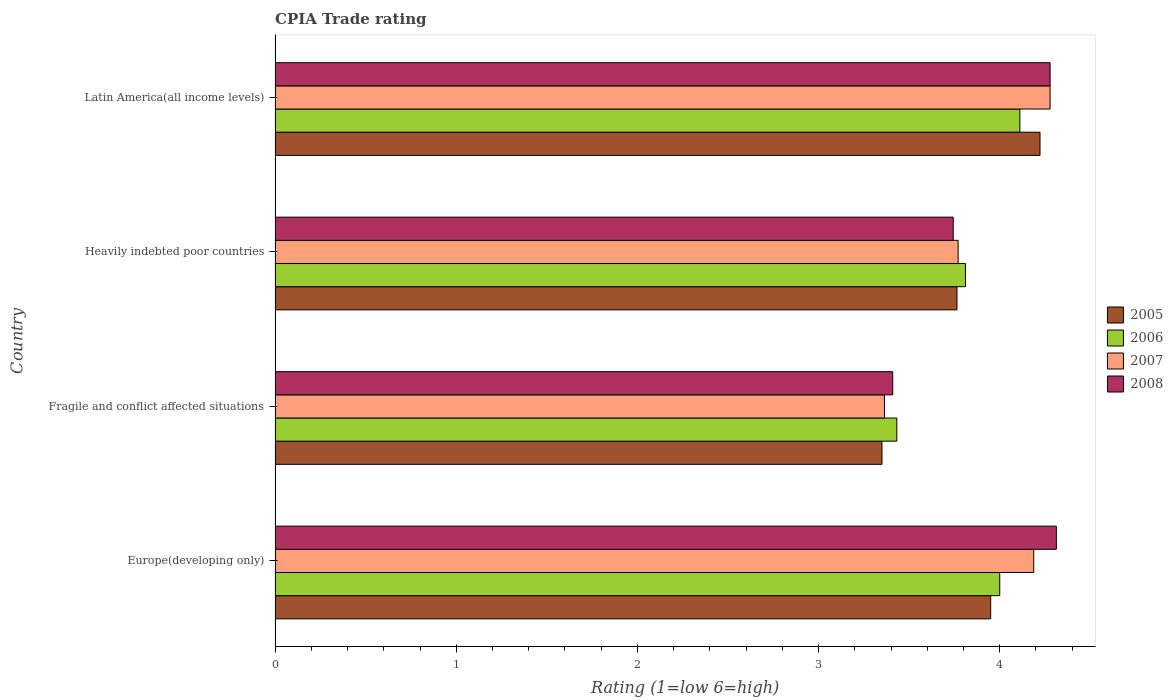Are the number of bars on each tick of the Y-axis equal?
Make the answer very short. Yes. What is the label of the 1st group of bars from the top?
Offer a very short reply. Latin America(all income levels). What is the CPIA rating in 2008 in Heavily indebted poor countries?
Ensure brevity in your answer.  3.74. Across all countries, what is the maximum CPIA rating in 2008?
Give a very brief answer. 4.31. Across all countries, what is the minimum CPIA rating in 2006?
Your answer should be very brief. 3.43. In which country was the CPIA rating in 2008 maximum?
Offer a very short reply. Europe(developing only). In which country was the CPIA rating in 2008 minimum?
Your response must be concise. Fragile and conflict affected situations. What is the total CPIA rating in 2007 in the graph?
Provide a succinct answer. 15.6. What is the difference between the CPIA rating in 2007 in Europe(developing only) and that in Fragile and conflict affected situations?
Your response must be concise. 0.82. What is the difference between the CPIA rating in 2008 in Heavily indebted poor countries and the CPIA rating in 2007 in Fragile and conflict affected situations?
Offer a terse response. 0.38. What is the average CPIA rating in 2007 per country?
Your answer should be very brief. 3.9. What is the difference between the CPIA rating in 2008 and CPIA rating in 2006 in Latin America(all income levels)?
Give a very brief answer. 0.17. In how many countries, is the CPIA rating in 2008 greater than 3.4 ?
Keep it short and to the point. 4. What is the ratio of the CPIA rating in 2005 in Fragile and conflict affected situations to that in Latin America(all income levels)?
Provide a succinct answer. 0.79. Is the difference between the CPIA rating in 2008 in Europe(developing only) and Fragile and conflict affected situations greater than the difference between the CPIA rating in 2006 in Europe(developing only) and Fragile and conflict affected situations?
Make the answer very short. Yes. What is the difference between the highest and the second highest CPIA rating in 2006?
Ensure brevity in your answer.  0.11. What is the difference between the highest and the lowest CPIA rating in 2008?
Offer a terse response. 0.9. Is the sum of the CPIA rating in 2008 in Heavily indebted poor countries and Latin America(all income levels) greater than the maximum CPIA rating in 2007 across all countries?
Provide a succinct answer. Yes. What does the 2nd bar from the top in Heavily indebted poor countries represents?
Offer a terse response. 2007. What does the 1st bar from the bottom in Heavily indebted poor countries represents?
Your answer should be very brief. 2005. Are all the bars in the graph horizontal?
Ensure brevity in your answer.  Yes. How many countries are there in the graph?
Provide a succinct answer. 4. What is the difference between two consecutive major ticks on the X-axis?
Your answer should be very brief. 1. Are the values on the major ticks of X-axis written in scientific E-notation?
Your response must be concise. No. Does the graph contain grids?
Offer a terse response. No. How many legend labels are there?
Offer a terse response. 4. How are the legend labels stacked?
Ensure brevity in your answer.  Vertical. What is the title of the graph?
Make the answer very short. CPIA Trade rating. Does "1967" appear as one of the legend labels in the graph?
Keep it short and to the point. No. What is the Rating (1=low 6=high) in 2005 in Europe(developing only)?
Offer a very short reply. 3.95. What is the Rating (1=low 6=high) of 2006 in Europe(developing only)?
Provide a succinct answer. 4. What is the Rating (1=low 6=high) in 2007 in Europe(developing only)?
Your answer should be compact. 4.19. What is the Rating (1=low 6=high) in 2008 in Europe(developing only)?
Keep it short and to the point. 4.31. What is the Rating (1=low 6=high) in 2005 in Fragile and conflict affected situations?
Offer a very short reply. 3.35. What is the Rating (1=low 6=high) of 2006 in Fragile and conflict affected situations?
Provide a succinct answer. 3.43. What is the Rating (1=low 6=high) in 2007 in Fragile and conflict affected situations?
Provide a short and direct response. 3.36. What is the Rating (1=low 6=high) of 2008 in Fragile and conflict affected situations?
Offer a terse response. 3.41. What is the Rating (1=low 6=high) of 2005 in Heavily indebted poor countries?
Your answer should be compact. 3.76. What is the Rating (1=low 6=high) in 2006 in Heavily indebted poor countries?
Give a very brief answer. 3.81. What is the Rating (1=low 6=high) in 2007 in Heavily indebted poor countries?
Keep it short and to the point. 3.77. What is the Rating (1=low 6=high) of 2008 in Heavily indebted poor countries?
Offer a very short reply. 3.74. What is the Rating (1=low 6=high) in 2005 in Latin America(all income levels)?
Ensure brevity in your answer.  4.22. What is the Rating (1=low 6=high) in 2006 in Latin America(all income levels)?
Your answer should be very brief. 4.11. What is the Rating (1=low 6=high) in 2007 in Latin America(all income levels)?
Your answer should be very brief. 4.28. What is the Rating (1=low 6=high) of 2008 in Latin America(all income levels)?
Make the answer very short. 4.28. Across all countries, what is the maximum Rating (1=low 6=high) in 2005?
Give a very brief answer. 4.22. Across all countries, what is the maximum Rating (1=low 6=high) in 2006?
Provide a short and direct response. 4.11. Across all countries, what is the maximum Rating (1=low 6=high) of 2007?
Offer a very short reply. 4.28. Across all countries, what is the maximum Rating (1=low 6=high) in 2008?
Provide a succinct answer. 4.31. Across all countries, what is the minimum Rating (1=low 6=high) in 2005?
Offer a terse response. 3.35. Across all countries, what is the minimum Rating (1=low 6=high) of 2006?
Offer a very short reply. 3.43. Across all countries, what is the minimum Rating (1=low 6=high) of 2007?
Make the answer very short. 3.36. Across all countries, what is the minimum Rating (1=low 6=high) of 2008?
Your answer should be very brief. 3.41. What is the total Rating (1=low 6=high) in 2005 in the graph?
Make the answer very short. 15.29. What is the total Rating (1=low 6=high) of 2006 in the graph?
Your answer should be very brief. 15.35. What is the total Rating (1=low 6=high) of 2007 in the graph?
Keep it short and to the point. 15.6. What is the total Rating (1=low 6=high) in 2008 in the graph?
Keep it short and to the point. 15.74. What is the difference between the Rating (1=low 6=high) of 2005 in Europe(developing only) and that in Fragile and conflict affected situations?
Give a very brief answer. 0.6. What is the difference between the Rating (1=low 6=high) of 2006 in Europe(developing only) and that in Fragile and conflict affected situations?
Your answer should be compact. 0.57. What is the difference between the Rating (1=low 6=high) of 2007 in Europe(developing only) and that in Fragile and conflict affected situations?
Your answer should be compact. 0.82. What is the difference between the Rating (1=low 6=high) of 2008 in Europe(developing only) and that in Fragile and conflict affected situations?
Your answer should be compact. 0.9. What is the difference between the Rating (1=low 6=high) of 2005 in Europe(developing only) and that in Heavily indebted poor countries?
Offer a very short reply. 0.19. What is the difference between the Rating (1=low 6=high) in 2006 in Europe(developing only) and that in Heavily indebted poor countries?
Give a very brief answer. 0.19. What is the difference between the Rating (1=low 6=high) of 2007 in Europe(developing only) and that in Heavily indebted poor countries?
Give a very brief answer. 0.42. What is the difference between the Rating (1=low 6=high) of 2008 in Europe(developing only) and that in Heavily indebted poor countries?
Provide a succinct answer. 0.57. What is the difference between the Rating (1=low 6=high) of 2005 in Europe(developing only) and that in Latin America(all income levels)?
Offer a very short reply. -0.27. What is the difference between the Rating (1=low 6=high) of 2006 in Europe(developing only) and that in Latin America(all income levels)?
Give a very brief answer. -0.11. What is the difference between the Rating (1=low 6=high) of 2007 in Europe(developing only) and that in Latin America(all income levels)?
Offer a terse response. -0.09. What is the difference between the Rating (1=low 6=high) of 2008 in Europe(developing only) and that in Latin America(all income levels)?
Your response must be concise. 0.03. What is the difference between the Rating (1=low 6=high) in 2005 in Fragile and conflict affected situations and that in Heavily indebted poor countries?
Offer a very short reply. -0.41. What is the difference between the Rating (1=low 6=high) of 2006 in Fragile and conflict affected situations and that in Heavily indebted poor countries?
Offer a very short reply. -0.38. What is the difference between the Rating (1=low 6=high) in 2007 in Fragile and conflict affected situations and that in Heavily indebted poor countries?
Your answer should be compact. -0.41. What is the difference between the Rating (1=low 6=high) in 2008 in Fragile and conflict affected situations and that in Heavily indebted poor countries?
Your answer should be compact. -0.33. What is the difference between the Rating (1=low 6=high) of 2005 in Fragile and conflict affected situations and that in Latin America(all income levels)?
Your answer should be compact. -0.87. What is the difference between the Rating (1=low 6=high) of 2006 in Fragile and conflict affected situations and that in Latin America(all income levels)?
Provide a short and direct response. -0.68. What is the difference between the Rating (1=low 6=high) of 2007 in Fragile and conflict affected situations and that in Latin America(all income levels)?
Your answer should be very brief. -0.91. What is the difference between the Rating (1=low 6=high) in 2008 in Fragile and conflict affected situations and that in Latin America(all income levels)?
Keep it short and to the point. -0.87. What is the difference between the Rating (1=low 6=high) of 2005 in Heavily indebted poor countries and that in Latin America(all income levels)?
Keep it short and to the point. -0.46. What is the difference between the Rating (1=low 6=high) of 2006 in Heavily indebted poor countries and that in Latin America(all income levels)?
Make the answer very short. -0.3. What is the difference between the Rating (1=low 6=high) of 2007 in Heavily indebted poor countries and that in Latin America(all income levels)?
Give a very brief answer. -0.51. What is the difference between the Rating (1=low 6=high) in 2008 in Heavily indebted poor countries and that in Latin America(all income levels)?
Give a very brief answer. -0.53. What is the difference between the Rating (1=low 6=high) in 2005 in Europe(developing only) and the Rating (1=low 6=high) in 2006 in Fragile and conflict affected situations?
Your answer should be very brief. 0.52. What is the difference between the Rating (1=low 6=high) in 2005 in Europe(developing only) and the Rating (1=low 6=high) in 2007 in Fragile and conflict affected situations?
Keep it short and to the point. 0.59. What is the difference between the Rating (1=low 6=high) in 2005 in Europe(developing only) and the Rating (1=low 6=high) in 2008 in Fragile and conflict affected situations?
Your answer should be compact. 0.54. What is the difference between the Rating (1=low 6=high) of 2006 in Europe(developing only) and the Rating (1=low 6=high) of 2007 in Fragile and conflict affected situations?
Offer a terse response. 0.64. What is the difference between the Rating (1=low 6=high) of 2006 in Europe(developing only) and the Rating (1=low 6=high) of 2008 in Fragile and conflict affected situations?
Provide a succinct answer. 0.59. What is the difference between the Rating (1=low 6=high) of 2007 in Europe(developing only) and the Rating (1=low 6=high) of 2008 in Fragile and conflict affected situations?
Give a very brief answer. 0.78. What is the difference between the Rating (1=low 6=high) in 2005 in Europe(developing only) and the Rating (1=low 6=high) in 2006 in Heavily indebted poor countries?
Keep it short and to the point. 0.14. What is the difference between the Rating (1=low 6=high) of 2005 in Europe(developing only) and the Rating (1=low 6=high) of 2007 in Heavily indebted poor countries?
Provide a succinct answer. 0.18. What is the difference between the Rating (1=low 6=high) of 2005 in Europe(developing only) and the Rating (1=low 6=high) of 2008 in Heavily indebted poor countries?
Make the answer very short. 0.21. What is the difference between the Rating (1=low 6=high) in 2006 in Europe(developing only) and the Rating (1=low 6=high) in 2007 in Heavily indebted poor countries?
Your answer should be compact. 0.23. What is the difference between the Rating (1=low 6=high) of 2006 in Europe(developing only) and the Rating (1=low 6=high) of 2008 in Heavily indebted poor countries?
Ensure brevity in your answer.  0.26. What is the difference between the Rating (1=low 6=high) in 2007 in Europe(developing only) and the Rating (1=low 6=high) in 2008 in Heavily indebted poor countries?
Give a very brief answer. 0.44. What is the difference between the Rating (1=low 6=high) of 2005 in Europe(developing only) and the Rating (1=low 6=high) of 2006 in Latin America(all income levels)?
Keep it short and to the point. -0.16. What is the difference between the Rating (1=low 6=high) of 2005 in Europe(developing only) and the Rating (1=low 6=high) of 2007 in Latin America(all income levels)?
Keep it short and to the point. -0.33. What is the difference between the Rating (1=low 6=high) in 2005 in Europe(developing only) and the Rating (1=low 6=high) in 2008 in Latin America(all income levels)?
Keep it short and to the point. -0.33. What is the difference between the Rating (1=low 6=high) in 2006 in Europe(developing only) and the Rating (1=low 6=high) in 2007 in Latin America(all income levels)?
Offer a very short reply. -0.28. What is the difference between the Rating (1=low 6=high) in 2006 in Europe(developing only) and the Rating (1=low 6=high) in 2008 in Latin America(all income levels)?
Make the answer very short. -0.28. What is the difference between the Rating (1=low 6=high) in 2007 in Europe(developing only) and the Rating (1=low 6=high) in 2008 in Latin America(all income levels)?
Provide a succinct answer. -0.09. What is the difference between the Rating (1=low 6=high) of 2005 in Fragile and conflict affected situations and the Rating (1=low 6=high) of 2006 in Heavily indebted poor countries?
Offer a very short reply. -0.46. What is the difference between the Rating (1=low 6=high) of 2005 in Fragile and conflict affected situations and the Rating (1=low 6=high) of 2007 in Heavily indebted poor countries?
Make the answer very short. -0.42. What is the difference between the Rating (1=low 6=high) in 2005 in Fragile and conflict affected situations and the Rating (1=low 6=high) in 2008 in Heavily indebted poor countries?
Keep it short and to the point. -0.39. What is the difference between the Rating (1=low 6=high) in 2006 in Fragile and conflict affected situations and the Rating (1=low 6=high) in 2007 in Heavily indebted poor countries?
Keep it short and to the point. -0.34. What is the difference between the Rating (1=low 6=high) of 2006 in Fragile and conflict affected situations and the Rating (1=low 6=high) of 2008 in Heavily indebted poor countries?
Provide a succinct answer. -0.31. What is the difference between the Rating (1=low 6=high) in 2007 in Fragile and conflict affected situations and the Rating (1=low 6=high) in 2008 in Heavily indebted poor countries?
Ensure brevity in your answer.  -0.38. What is the difference between the Rating (1=low 6=high) in 2005 in Fragile and conflict affected situations and the Rating (1=low 6=high) in 2006 in Latin America(all income levels)?
Provide a short and direct response. -0.76. What is the difference between the Rating (1=low 6=high) of 2005 in Fragile and conflict affected situations and the Rating (1=low 6=high) of 2007 in Latin America(all income levels)?
Offer a terse response. -0.93. What is the difference between the Rating (1=low 6=high) of 2005 in Fragile and conflict affected situations and the Rating (1=low 6=high) of 2008 in Latin America(all income levels)?
Offer a very short reply. -0.93. What is the difference between the Rating (1=low 6=high) of 2006 in Fragile and conflict affected situations and the Rating (1=low 6=high) of 2007 in Latin America(all income levels)?
Provide a succinct answer. -0.85. What is the difference between the Rating (1=low 6=high) in 2006 in Fragile and conflict affected situations and the Rating (1=low 6=high) in 2008 in Latin America(all income levels)?
Provide a short and direct response. -0.85. What is the difference between the Rating (1=low 6=high) of 2007 in Fragile and conflict affected situations and the Rating (1=low 6=high) of 2008 in Latin America(all income levels)?
Your answer should be compact. -0.91. What is the difference between the Rating (1=low 6=high) in 2005 in Heavily indebted poor countries and the Rating (1=low 6=high) in 2006 in Latin America(all income levels)?
Provide a short and direct response. -0.35. What is the difference between the Rating (1=low 6=high) in 2005 in Heavily indebted poor countries and the Rating (1=low 6=high) in 2007 in Latin America(all income levels)?
Offer a terse response. -0.51. What is the difference between the Rating (1=low 6=high) in 2005 in Heavily indebted poor countries and the Rating (1=low 6=high) in 2008 in Latin America(all income levels)?
Give a very brief answer. -0.51. What is the difference between the Rating (1=low 6=high) in 2006 in Heavily indebted poor countries and the Rating (1=low 6=high) in 2007 in Latin America(all income levels)?
Keep it short and to the point. -0.47. What is the difference between the Rating (1=low 6=high) of 2006 in Heavily indebted poor countries and the Rating (1=low 6=high) of 2008 in Latin America(all income levels)?
Provide a succinct answer. -0.47. What is the difference between the Rating (1=low 6=high) of 2007 in Heavily indebted poor countries and the Rating (1=low 6=high) of 2008 in Latin America(all income levels)?
Make the answer very short. -0.51. What is the average Rating (1=low 6=high) of 2005 per country?
Your response must be concise. 3.82. What is the average Rating (1=low 6=high) of 2006 per country?
Offer a very short reply. 3.84. What is the average Rating (1=low 6=high) of 2007 per country?
Make the answer very short. 3.9. What is the average Rating (1=low 6=high) of 2008 per country?
Provide a short and direct response. 3.94. What is the difference between the Rating (1=low 6=high) of 2005 and Rating (1=low 6=high) of 2006 in Europe(developing only)?
Offer a terse response. -0.05. What is the difference between the Rating (1=low 6=high) in 2005 and Rating (1=low 6=high) in 2007 in Europe(developing only)?
Your answer should be compact. -0.24. What is the difference between the Rating (1=low 6=high) in 2005 and Rating (1=low 6=high) in 2008 in Europe(developing only)?
Your answer should be compact. -0.36. What is the difference between the Rating (1=low 6=high) of 2006 and Rating (1=low 6=high) of 2007 in Europe(developing only)?
Your response must be concise. -0.19. What is the difference between the Rating (1=low 6=high) in 2006 and Rating (1=low 6=high) in 2008 in Europe(developing only)?
Give a very brief answer. -0.31. What is the difference between the Rating (1=low 6=high) of 2007 and Rating (1=low 6=high) of 2008 in Europe(developing only)?
Your response must be concise. -0.12. What is the difference between the Rating (1=low 6=high) in 2005 and Rating (1=low 6=high) in 2006 in Fragile and conflict affected situations?
Your response must be concise. -0.08. What is the difference between the Rating (1=low 6=high) of 2005 and Rating (1=low 6=high) of 2007 in Fragile and conflict affected situations?
Provide a short and direct response. -0.01. What is the difference between the Rating (1=low 6=high) in 2005 and Rating (1=low 6=high) in 2008 in Fragile and conflict affected situations?
Make the answer very short. -0.06. What is the difference between the Rating (1=low 6=high) of 2006 and Rating (1=low 6=high) of 2007 in Fragile and conflict affected situations?
Provide a short and direct response. 0.07. What is the difference between the Rating (1=low 6=high) of 2006 and Rating (1=low 6=high) of 2008 in Fragile and conflict affected situations?
Provide a short and direct response. 0.02. What is the difference between the Rating (1=low 6=high) in 2007 and Rating (1=low 6=high) in 2008 in Fragile and conflict affected situations?
Ensure brevity in your answer.  -0.05. What is the difference between the Rating (1=low 6=high) of 2005 and Rating (1=low 6=high) of 2006 in Heavily indebted poor countries?
Keep it short and to the point. -0.05. What is the difference between the Rating (1=low 6=high) in 2005 and Rating (1=low 6=high) in 2007 in Heavily indebted poor countries?
Keep it short and to the point. -0.01. What is the difference between the Rating (1=low 6=high) in 2005 and Rating (1=low 6=high) in 2008 in Heavily indebted poor countries?
Offer a very short reply. 0.02. What is the difference between the Rating (1=low 6=high) of 2006 and Rating (1=low 6=high) of 2007 in Heavily indebted poor countries?
Offer a very short reply. 0.04. What is the difference between the Rating (1=low 6=high) in 2006 and Rating (1=low 6=high) in 2008 in Heavily indebted poor countries?
Offer a terse response. 0.07. What is the difference between the Rating (1=low 6=high) in 2007 and Rating (1=low 6=high) in 2008 in Heavily indebted poor countries?
Your answer should be compact. 0.03. What is the difference between the Rating (1=low 6=high) in 2005 and Rating (1=low 6=high) in 2007 in Latin America(all income levels)?
Offer a very short reply. -0.06. What is the difference between the Rating (1=low 6=high) of 2005 and Rating (1=low 6=high) of 2008 in Latin America(all income levels)?
Your answer should be compact. -0.06. What is the difference between the Rating (1=low 6=high) in 2006 and Rating (1=low 6=high) in 2008 in Latin America(all income levels)?
Your answer should be compact. -0.17. What is the ratio of the Rating (1=low 6=high) in 2005 in Europe(developing only) to that in Fragile and conflict affected situations?
Your answer should be very brief. 1.18. What is the ratio of the Rating (1=low 6=high) in 2006 in Europe(developing only) to that in Fragile and conflict affected situations?
Offer a terse response. 1.17. What is the ratio of the Rating (1=low 6=high) in 2007 in Europe(developing only) to that in Fragile and conflict affected situations?
Offer a terse response. 1.24. What is the ratio of the Rating (1=low 6=high) in 2008 in Europe(developing only) to that in Fragile and conflict affected situations?
Your answer should be very brief. 1.26. What is the ratio of the Rating (1=low 6=high) of 2005 in Europe(developing only) to that in Heavily indebted poor countries?
Ensure brevity in your answer.  1.05. What is the ratio of the Rating (1=low 6=high) in 2006 in Europe(developing only) to that in Heavily indebted poor countries?
Give a very brief answer. 1.05. What is the ratio of the Rating (1=low 6=high) of 2007 in Europe(developing only) to that in Heavily indebted poor countries?
Make the answer very short. 1.11. What is the ratio of the Rating (1=low 6=high) of 2008 in Europe(developing only) to that in Heavily indebted poor countries?
Your answer should be compact. 1.15. What is the ratio of the Rating (1=low 6=high) of 2005 in Europe(developing only) to that in Latin America(all income levels)?
Your answer should be very brief. 0.94. What is the ratio of the Rating (1=low 6=high) of 2006 in Europe(developing only) to that in Latin America(all income levels)?
Make the answer very short. 0.97. What is the ratio of the Rating (1=low 6=high) in 2007 in Europe(developing only) to that in Latin America(all income levels)?
Provide a short and direct response. 0.98. What is the ratio of the Rating (1=low 6=high) of 2005 in Fragile and conflict affected situations to that in Heavily indebted poor countries?
Your answer should be very brief. 0.89. What is the ratio of the Rating (1=low 6=high) of 2006 in Fragile and conflict affected situations to that in Heavily indebted poor countries?
Give a very brief answer. 0.9. What is the ratio of the Rating (1=low 6=high) in 2007 in Fragile and conflict affected situations to that in Heavily indebted poor countries?
Your response must be concise. 0.89. What is the ratio of the Rating (1=low 6=high) of 2008 in Fragile and conflict affected situations to that in Heavily indebted poor countries?
Give a very brief answer. 0.91. What is the ratio of the Rating (1=low 6=high) in 2005 in Fragile and conflict affected situations to that in Latin America(all income levels)?
Ensure brevity in your answer.  0.79. What is the ratio of the Rating (1=low 6=high) in 2006 in Fragile and conflict affected situations to that in Latin America(all income levels)?
Offer a very short reply. 0.83. What is the ratio of the Rating (1=low 6=high) in 2007 in Fragile and conflict affected situations to that in Latin America(all income levels)?
Give a very brief answer. 0.79. What is the ratio of the Rating (1=low 6=high) in 2008 in Fragile and conflict affected situations to that in Latin America(all income levels)?
Offer a very short reply. 0.8. What is the ratio of the Rating (1=low 6=high) of 2005 in Heavily indebted poor countries to that in Latin America(all income levels)?
Provide a short and direct response. 0.89. What is the ratio of the Rating (1=low 6=high) in 2006 in Heavily indebted poor countries to that in Latin America(all income levels)?
Offer a terse response. 0.93. What is the ratio of the Rating (1=low 6=high) in 2007 in Heavily indebted poor countries to that in Latin America(all income levels)?
Your answer should be compact. 0.88. What is the difference between the highest and the second highest Rating (1=low 6=high) in 2005?
Your answer should be very brief. 0.27. What is the difference between the highest and the second highest Rating (1=low 6=high) of 2007?
Ensure brevity in your answer.  0.09. What is the difference between the highest and the second highest Rating (1=low 6=high) of 2008?
Your answer should be compact. 0.03. What is the difference between the highest and the lowest Rating (1=low 6=high) in 2005?
Offer a very short reply. 0.87. What is the difference between the highest and the lowest Rating (1=low 6=high) in 2006?
Provide a succinct answer. 0.68. What is the difference between the highest and the lowest Rating (1=low 6=high) of 2007?
Give a very brief answer. 0.91. What is the difference between the highest and the lowest Rating (1=low 6=high) of 2008?
Make the answer very short. 0.9. 